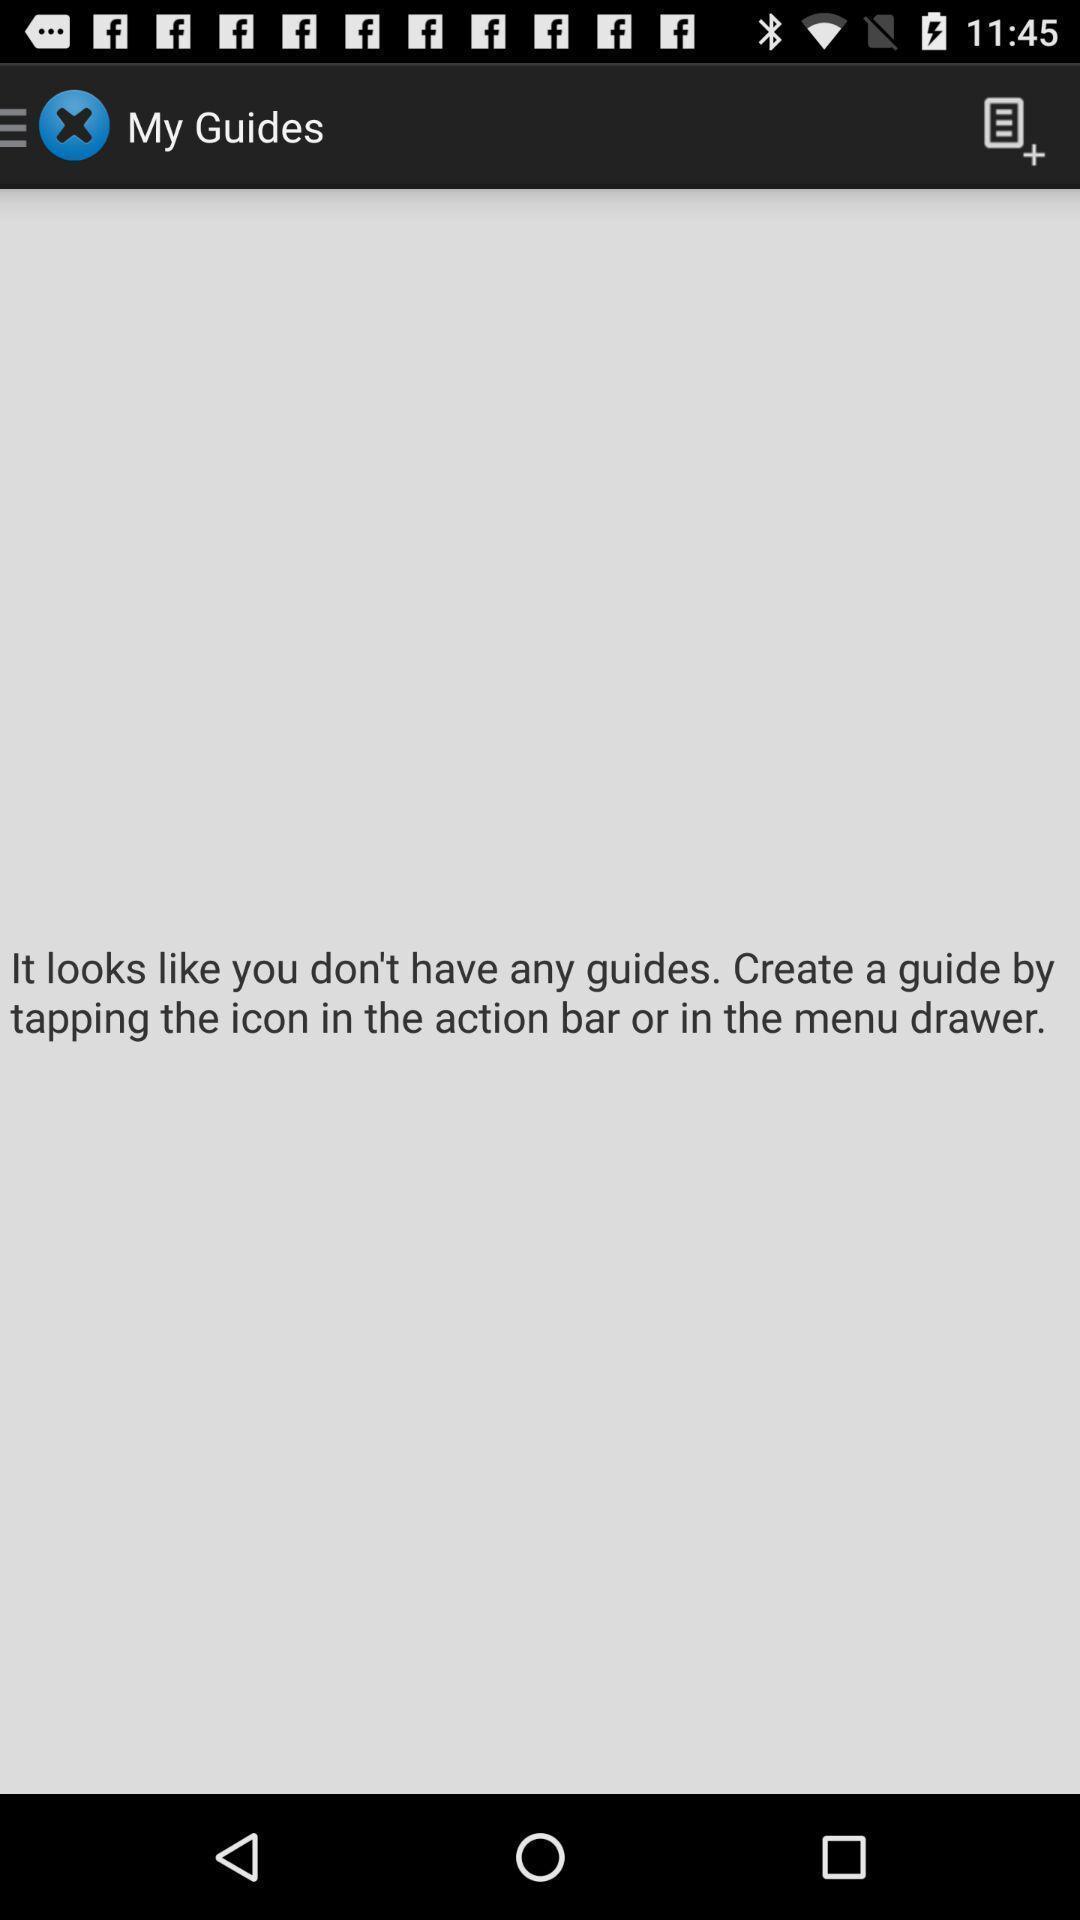Provide a detailed account of this screenshot. Screen displaying information to access the application. 